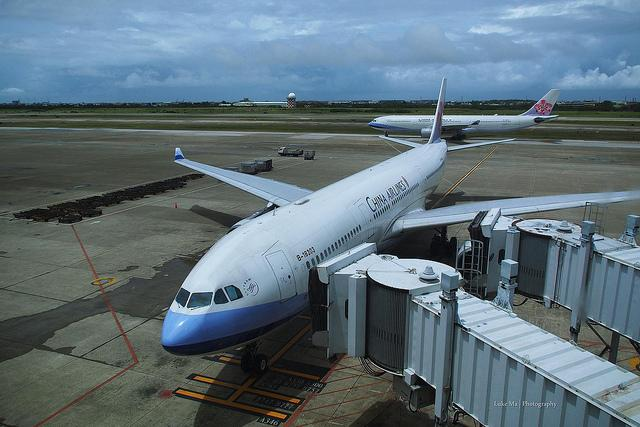What is the tunnel nearest the plane door called? aerobridge 